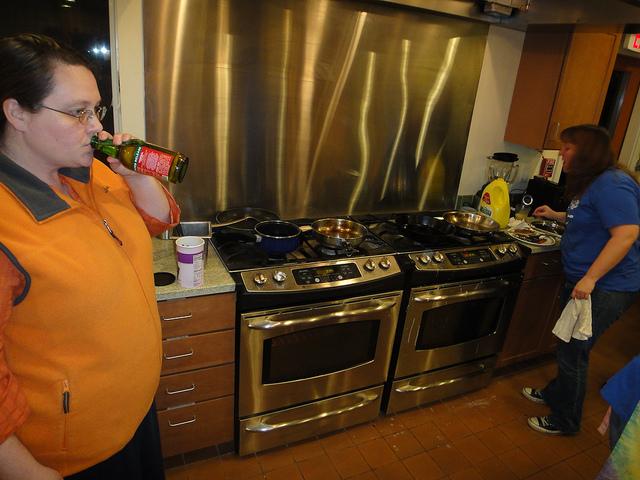Is the person in orange a man or a woman?
Answer briefly. Woman. Where are they?
Write a very short answer. Kitchen. Is the man showing off?
Keep it brief. No. What pattern is the woman's shirt?
Give a very brief answer. Solid. Are there any people in the photo?
Be succinct. Yes. What color are her shoes?
Write a very short answer. Black and white. Do these people look happy?
Be succinct. No. What color is the image?
Give a very brief answer. Brown. Are they going somewhere?
Write a very short answer. No. What is the person in the blue shirt doing?
Answer briefly. Cooking. Where are the portraits?
Keep it brief. None. What color is the bottle?
Concise answer only. Green. How many handles are in the picture?
Concise answer only. 8. Which room is this?
Give a very brief answer. Kitchen. What are they looking into?
Answer briefly. Pan. What is in the man's mouth?
Answer briefly. Beer. Is this man bald?
Keep it brief. No. What vegetable is the man holding?
Write a very short answer. Beer. What are those two things?
Concise answer only. Stoves. Is this man wearing glasses to look cool?
Be succinct. No. Is there a trip being planned?
Answer briefly. No. How many dishtowels are on the stove?
Keep it brief. 0. Is there a remote control in the picture?
Short answer required. No. What color is the stove?
Write a very short answer. Silver. How many shirt are there?
Keep it brief. 2. What color shoes is she wearing?
Quick response, please. Black and white. Is there a computer mouse in this photo?
Write a very short answer. No. What are they drinking?
Concise answer only. Beer. What color are the curtains?
Be succinct. Gold. Is he drinking beer?
Concise answer only. Yes. What is the man doing?
Concise answer only. Drinking. Are there bottles of liquor on the counter?
Be succinct. No. What type of hairstyle does this person have?
Be succinct. Short. Is he a girl?
Write a very short answer. No. Are these stoves gas or electric?
Answer briefly. Gas. Is this a gas range?
Write a very short answer. Yes. What is the man holding?
Write a very short answer. Beer. Is it sunny outside?
Write a very short answer. No. What is this person about the step on?
Concise answer only. Floor. What is being made?
Answer briefly. Food. What is the woman on the right holding?
Write a very short answer. Towel. What room is she in?
Keep it brief. Kitchen. Is the range on?
Write a very short answer. Yes. Is the burner on?
Write a very short answer. Yes. Are they bent over?
Write a very short answer. No. How many pairs of shoes?
Quick response, please. 1. Is he wearing a vest?
Answer briefly. Yes. Is the person wearing shoes?
Quick response, please. Yes. What color is the man's vest?
Short answer required. Orange. What is in the man's hand?
Short answer required. Bottle. What is the woman standing up holding?
Keep it brief. Beer. What kind of room is this?
Answer briefly. Kitchen. What holiday is this?
Concise answer only. Thanksgiving. How many men are in the picture?
Keep it brief. 0. Do these people look like they're celebrating?
Be succinct. Yes. What are they cleaning?
Keep it brief. No. Are the people happy?
Be succinct. Yes. Are they having fun?
Keep it brief. Yes. How many animals are on the floor?
Write a very short answer. 0. What color is on his shirt?
Concise answer only. Orange. Is this a kitchen?
Answer briefly. Yes. Is this stove electric or gas?
Quick response, please. Gas. What color is the woman's glass frames?
Give a very brief answer. Brown. What color is the fire?
Short answer required. Blue. Is the girl in the front happy?
Short answer required. No. What kind of beverage are they most likely drinking?
Keep it brief. Beer. Is the man smoking a cigarette?
Quick response, please. No. What brand is pictured on the shirt of the man wearing orange?
Quick response, please. Polo. Does the man have a mustache?
Keep it brief. No. Is the man using a folk?
Keep it brief. No. How many stoves are there?
Give a very brief answer. 2. Are they in a gym?
Give a very brief answer. No. What is in the yellow bottle?
Write a very short answer. Oil. What is in the bowl?
Concise answer only. Food. What is this woman sitting on?
Give a very brief answer. Nothing. Are both women working on laptops?
Give a very brief answer. No. How many pots are on the stove?
Give a very brief answer. 4. What color is the thermos on the stove?
Answer briefly. Black. Who many women are?
Give a very brief answer. 2. What are the people doing?
Short answer required. Cooking. Are they both women?
Give a very brief answer. Yes. What are these people doing?
Concise answer only. Drinking. Where are these people?
Concise answer only. Kitchen. What sport does the girl play?
Short answer required. None. What are these woman making?
Write a very short answer. Food. Does the woman have diabetes?
Write a very short answer. No. Is this scene outdoors?
Answer briefly. No. What is this person eating?
Give a very brief answer. Beer. What are these people holding?
Short answer required. Beer. Are the people old?
Keep it brief. No. Is the woman looking at the camera?
Answer briefly. No. Where are the strawberry seeds?
Keep it brief. Your best guess. What is the man holding in his mouth?
Give a very brief answer. Bottle. What is written on the wrap?
Quick response, please. Ingredients. What did the woman most likely drink?
Answer briefly. Beer. What is on the floor in the back?
Answer briefly. Food. Does there appear to be smoke in the room?
Be succinct. No. Would you find alcohol at this party?
Concise answer only. Yes. How many pizza's are on the cutting board?
Give a very brief answer. 0. What country is represented in the picture?
Concise answer only. Usa. Is this women drunk?
Concise answer only. No. What is the woman holding?
Quick response, please. Beer. Is this a dog's leg?
Be succinct. No. What is she holding?
Quick response, please. Beer. What color is the lid on the pot?
Concise answer only. Silver. Is the mans arm hairy?
Quick response, please. No. Where is this place?
Concise answer only. Kitchen. Are both people wearing shoes?
Write a very short answer. Yes. Is this a meeting?
Be succinct. No. What this girl is preparing?
Write a very short answer. Food. What color is her shirt?
Concise answer only. Blue. What kind of oven is in the background?
Answer briefly. Gas. How many people?
Keep it brief. 2. Based on the decor and food, in which country do you think this meal is being consumed?
Quick response, please. Usa. What device is this couple likely using to listen to music?
Concise answer only. Radio. What is in the lady's mouth?
Give a very brief answer. Beer. What color is the woman's jacket?
Write a very short answer. Orange. What is the man eating?
Short answer required. Beer. Who has blue jeans on?
Concise answer only. Woman. Is the woman on the far right of the image drinking from the bottle?
Quick response, please. No. Is the person shown an American?
Give a very brief answer. Yes. What soft drink brand is the parent company of this water brand?
Short answer required. Coca cola. How many piercings does the girl have in her ear?
Be succinct. 0. What is at the top of the grill?
Be succinct. Pan. Is this person looking at a video screen?
Give a very brief answer. No. How many shoes can you see?
Give a very brief answer. 2. Who is drinking?
Quick response, please. Woman. Is this woman hungry?
Be succinct. Yes. How many people are in the picture?
Give a very brief answer. 2. What color are the frames of the women's glasses?
Write a very short answer. Black. Is the woman closing the oven or taking the dish out?
Keep it brief. Taking dish out. How many women are visible in the background?
Concise answer only. 1. What type of alcohol is this?
Quick response, please. Beer. Is it appropriate to wear orange on this day?
Give a very brief answer. Yes. Is this person right-handed?
Quick response, please. No. What color is the kitchen towel?
Keep it brief. White. What does the glass contain?
Be succinct. Beer. 